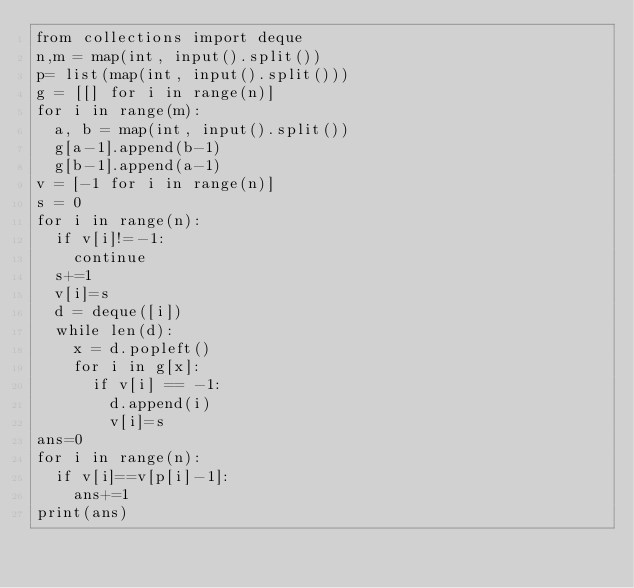<code> <loc_0><loc_0><loc_500><loc_500><_Python_>from collections import deque
n,m = map(int, input().split())
p= list(map(int, input().split()))
g = [[] for i in range(n)]
for i in range(m):
  a, b = map(int, input().split())
  g[a-1].append(b-1)
  g[b-1].append(a-1)
v = [-1 for i in range(n)]
s = 0
for i in range(n):
  if v[i]!=-1:
    continue
  s+=1
  v[i]=s
  d = deque([i])
  while len(d):
    x = d.popleft()
    for i in g[x]:
      if v[i] == -1:
        d.append(i)
        v[i]=s
ans=0
for i in range(n):
  if v[i]==v[p[i]-1]:
    ans+=1
print(ans)</code> 